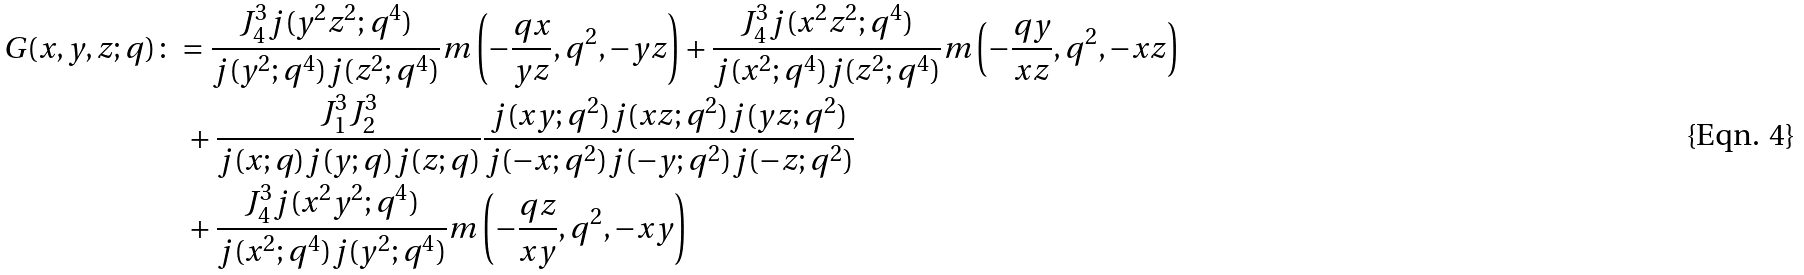Convert formula to latex. <formula><loc_0><loc_0><loc_500><loc_500>G ( x , y , z ; q ) & \colon = \frac { J _ { 4 } ^ { 3 } j ( y ^ { 2 } z ^ { 2 } ; q ^ { 4 } ) } { j ( y ^ { 2 } ; q ^ { 4 } ) j ( z ^ { 2 } ; q ^ { 4 } ) } m \left ( - \frac { q x } { y z } , q ^ { 2 } , - y z \right ) + \frac { J _ { 4 } ^ { 3 } j ( x ^ { 2 } z ^ { 2 } ; q ^ { 4 } ) } { j ( x ^ { 2 } ; q ^ { 4 } ) j ( z ^ { 2 } ; q ^ { 4 } ) } m \left ( - \frac { q y } { x z } , q ^ { 2 } , - x z \right ) \\ & \quad + \frac { J _ { 1 } ^ { 3 } J _ { 2 } ^ { 3 } } { j ( x ; q ) j ( y ; q ) j ( z ; q ) } \frac { j ( x y ; q ^ { 2 } ) j ( x z ; q ^ { 2 } ) j ( y z ; q ^ { 2 } ) } { j ( - x ; q ^ { 2 } ) j ( - y ; q ^ { 2 } ) j ( - z ; q ^ { 2 } ) } \\ & \quad + \frac { J _ { 4 } ^ { 3 } j ( x ^ { 2 } y ^ { 2 } ; q ^ { 4 } ) } { j ( x ^ { 2 } ; q ^ { 4 } ) j ( y ^ { 2 } ; q ^ { 4 } ) } m \left ( - \frac { q z } { x y } , q ^ { 2 } , - x y \right )</formula> 